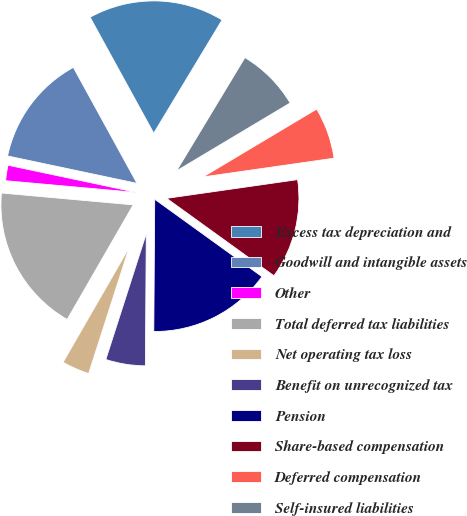<chart> <loc_0><loc_0><loc_500><loc_500><pie_chart><fcel>Excess tax depreciation and<fcel>Goodwill and intangible assets<fcel>Other<fcel>Total deferred tax liabilities<fcel>Net operating tax loss<fcel>Benefit on unrecognized tax<fcel>Pension<fcel>Share-based compensation<fcel>Deferred compensation<fcel>Self-insured liabilities<nl><fcel>16.63%<fcel>13.69%<fcel>1.89%<fcel>18.11%<fcel>3.37%<fcel>4.84%<fcel>15.16%<fcel>12.21%<fcel>6.31%<fcel>7.79%<nl></chart> 